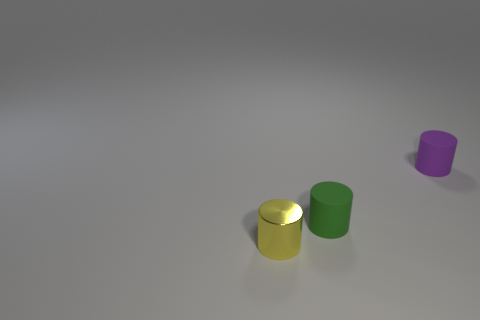What color is the object that is both behind the metallic thing and left of the small purple object?
Offer a very short reply. Green. What is the material of the small yellow thing?
Offer a terse response. Metal. Does the tiny green thing have the same material as the thing to the right of the tiny green thing?
Give a very brief answer. Yes. Is there any other thing that is the same color as the tiny metallic cylinder?
Make the answer very short. No. There is a tiny object that is in front of the matte cylinder that is left of the purple thing; are there any rubber cylinders on the right side of it?
Offer a very short reply. Yes. The metal object has what color?
Your answer should be compact. Yellow. There is a metal thing; are there any small yellow metal cylinders on the right side of it?
Your answer should be compact. No. Is the shape of the green matte thing the same as the thing that is to the left of the green object?
Your answer should be very brief. Yes. What number of other objects are there of the same material as the small yellow object?
Provide a short and direct response. 0. There is a rubber cylinder on the right side of the small matte thing in front of the small purple cylinder that is to the right of the small green matte object; what is its color?
Make the answer very short. Purple. 